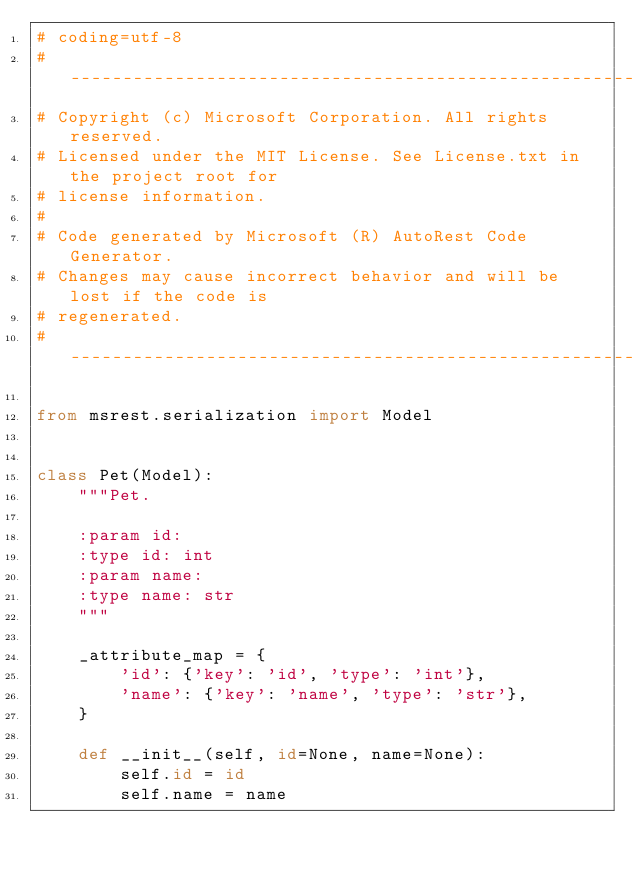Convert code to text. <code><loc_0><loc_0><loc_500><loc_500><_Python_># coding=utf-8
# --------------------------------------------------------------------------
# Copyright (c) Microsoft Corporation. All rights reserved.
# Licensed under the MIT License. See License.txt in the project root for
# license information.
#
# Code generated by Microsoft (R) AutoRest Code Generator.
# Changes may cause incorrect behavior and will be lost if the code is
# regenerated.
# --------------------------------------------------------------------------

from msrest.serialization import Model


class Pet(Model):
    """Pet.

    :param id:
    :type id: int
    :param name:
    :type name: str
    """ 

    _attribute_map = {
        'id': {'key': 'id', 'type': 'int'},
        'name': {'key': 'name', 'type': 'str'},
    }

    def __init__(self, id=None, name=None):
        self.id = id
        self.name = name
</code> 